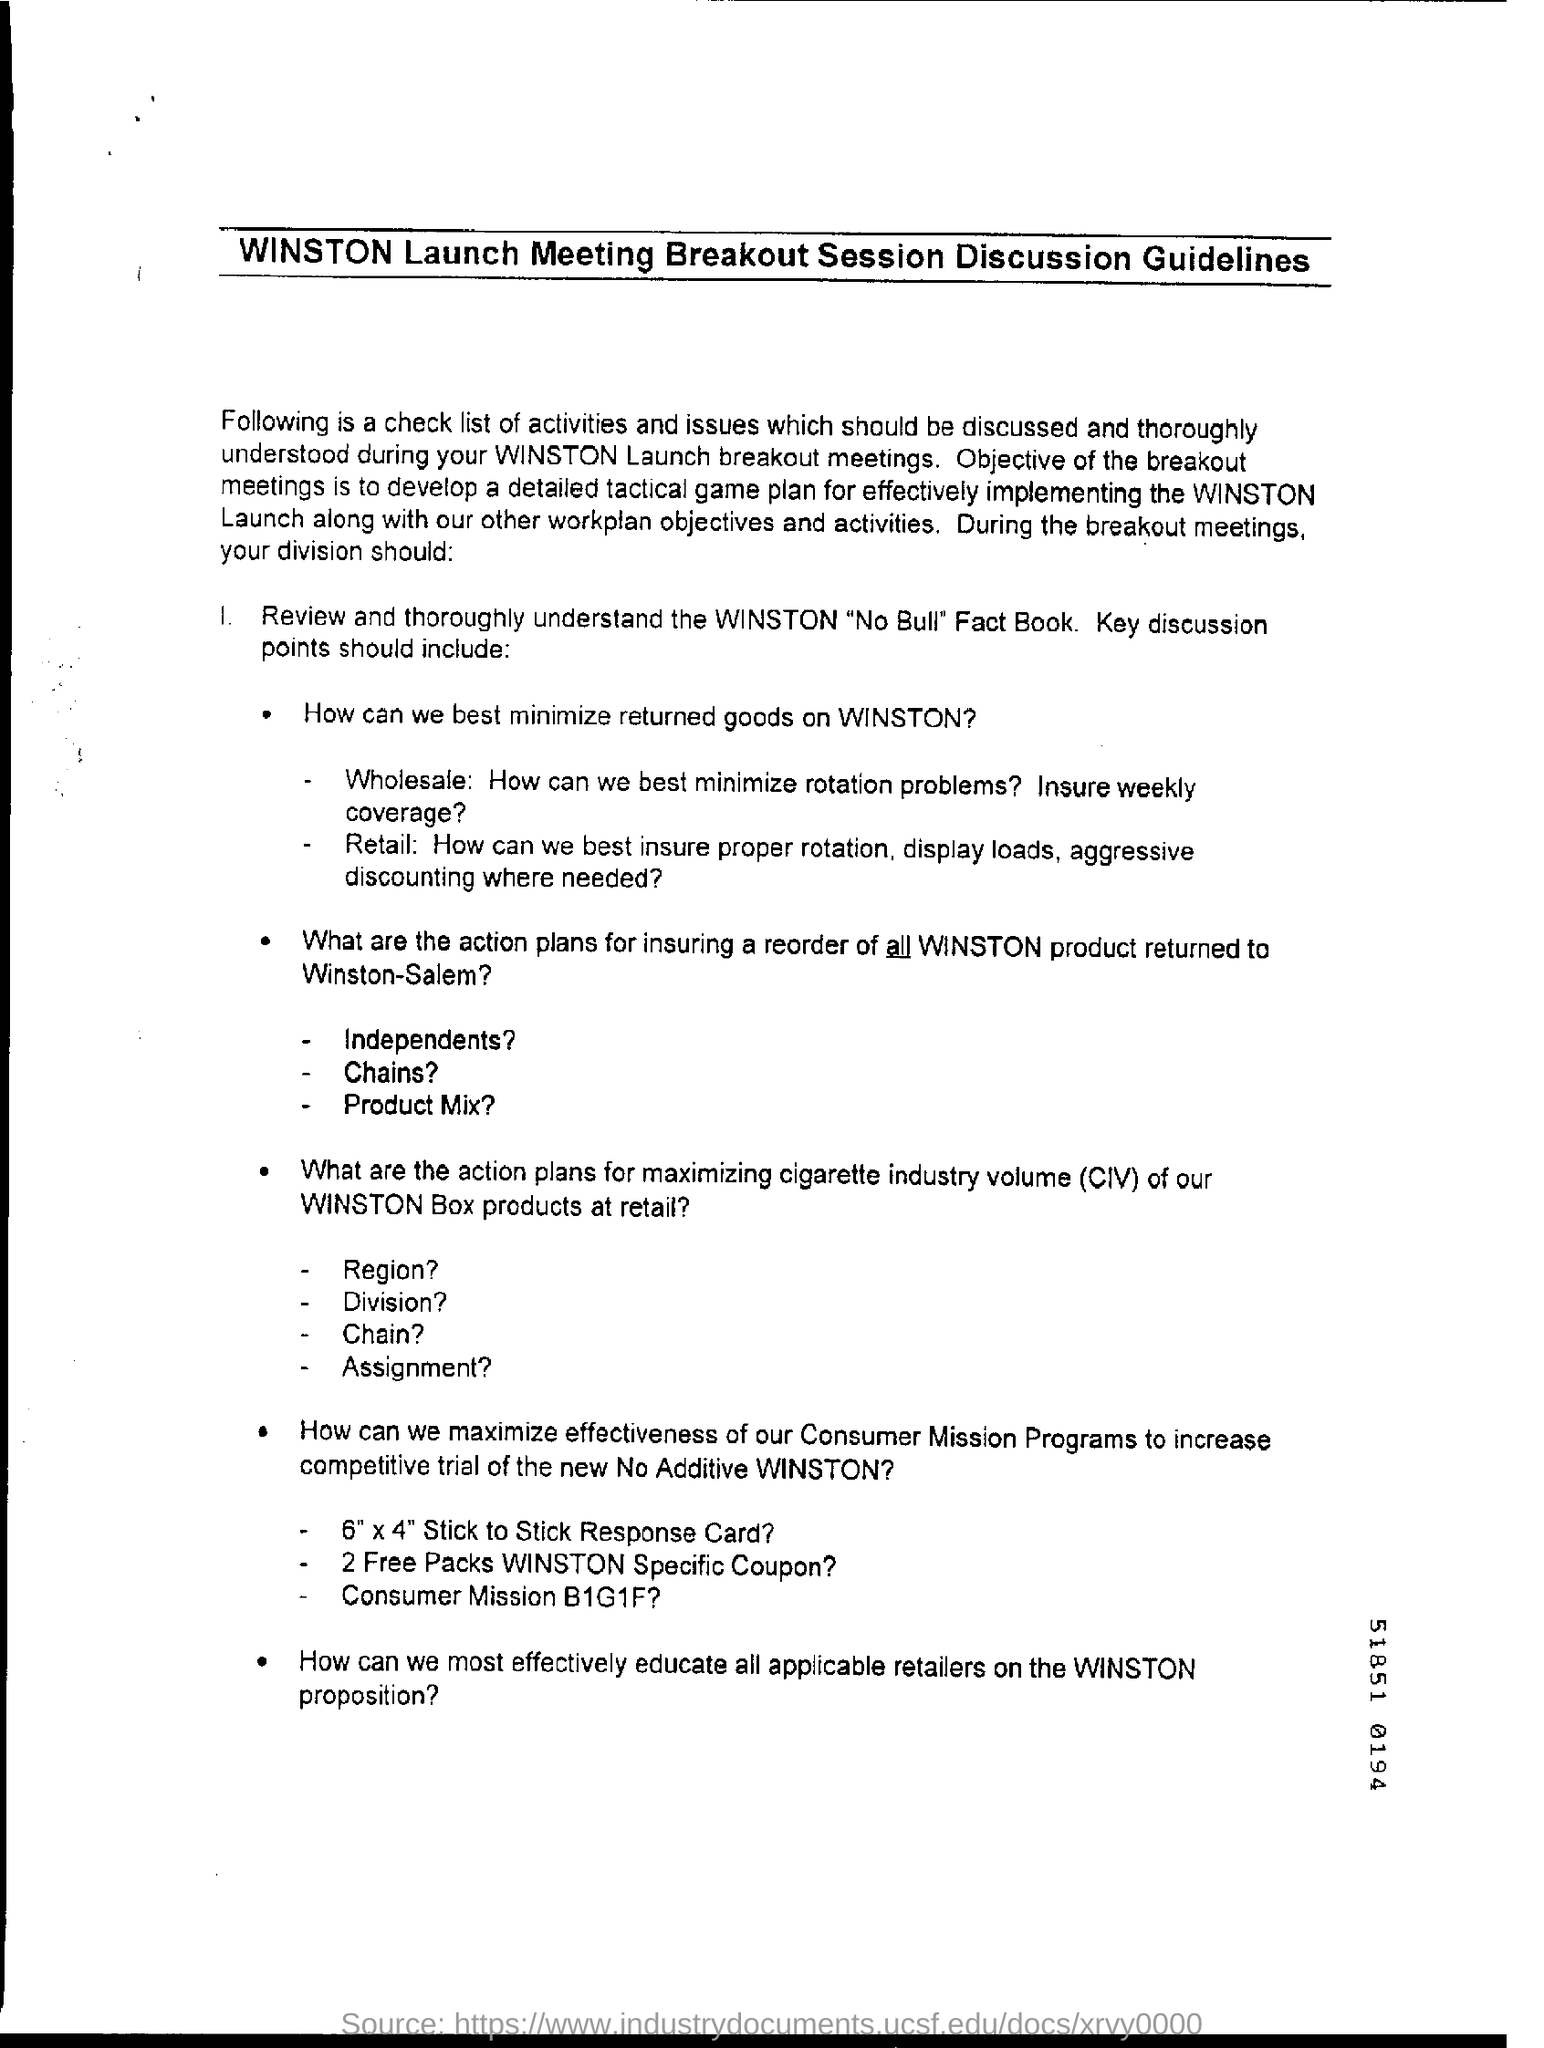Point out several critical features in this image. CIV stands for "Cigarette Industry Volume," which refers to the total quantity of cigarettes produced or sold by the industry in a given time period. 